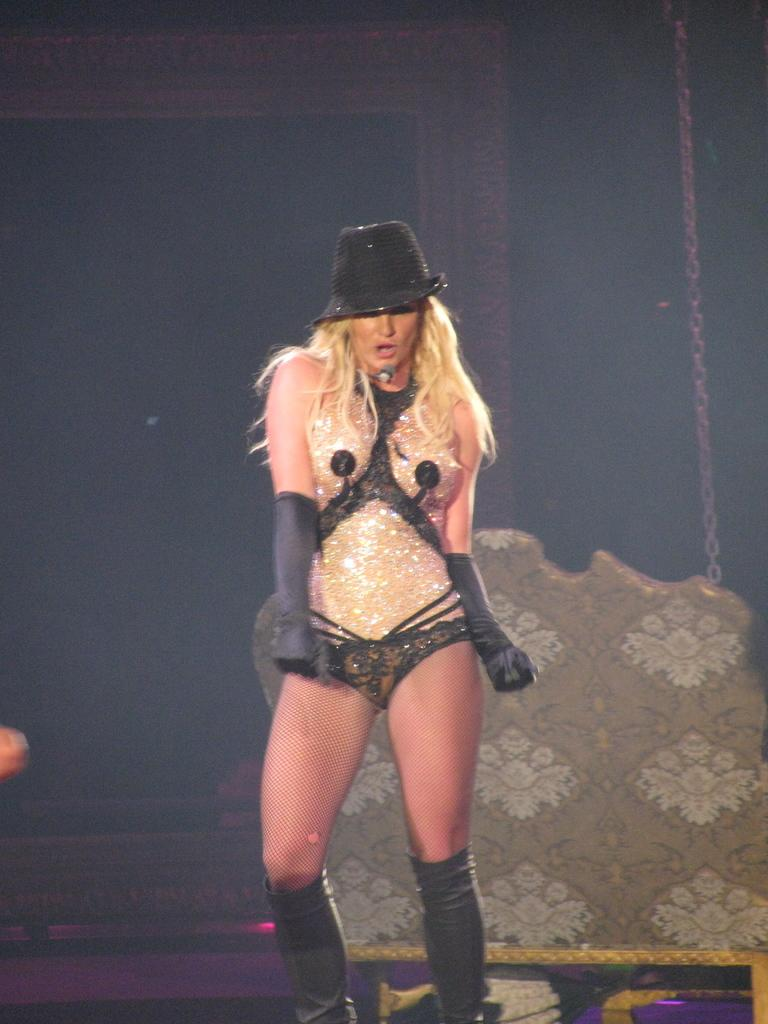What is the woman in the image doing? The woman is singing and dancing in the image. What is the woman wearing on her head? The woman is wearing a hat in the image. What is the woman holding while singing and dancing? The woman is holding a microphone in the image. What is the woman wearing on her hands? The woman is wearing gloves in the image. What can be seen in the background of the image? There is a chain visible in the background of the image, and the background has a dark view. What is the purpose of the sheep in the image? There are no sheep present in the image. What type of skin does the woman have in the image? The image does not provide information about the woman's skin, so it cannot be determined from the image. 